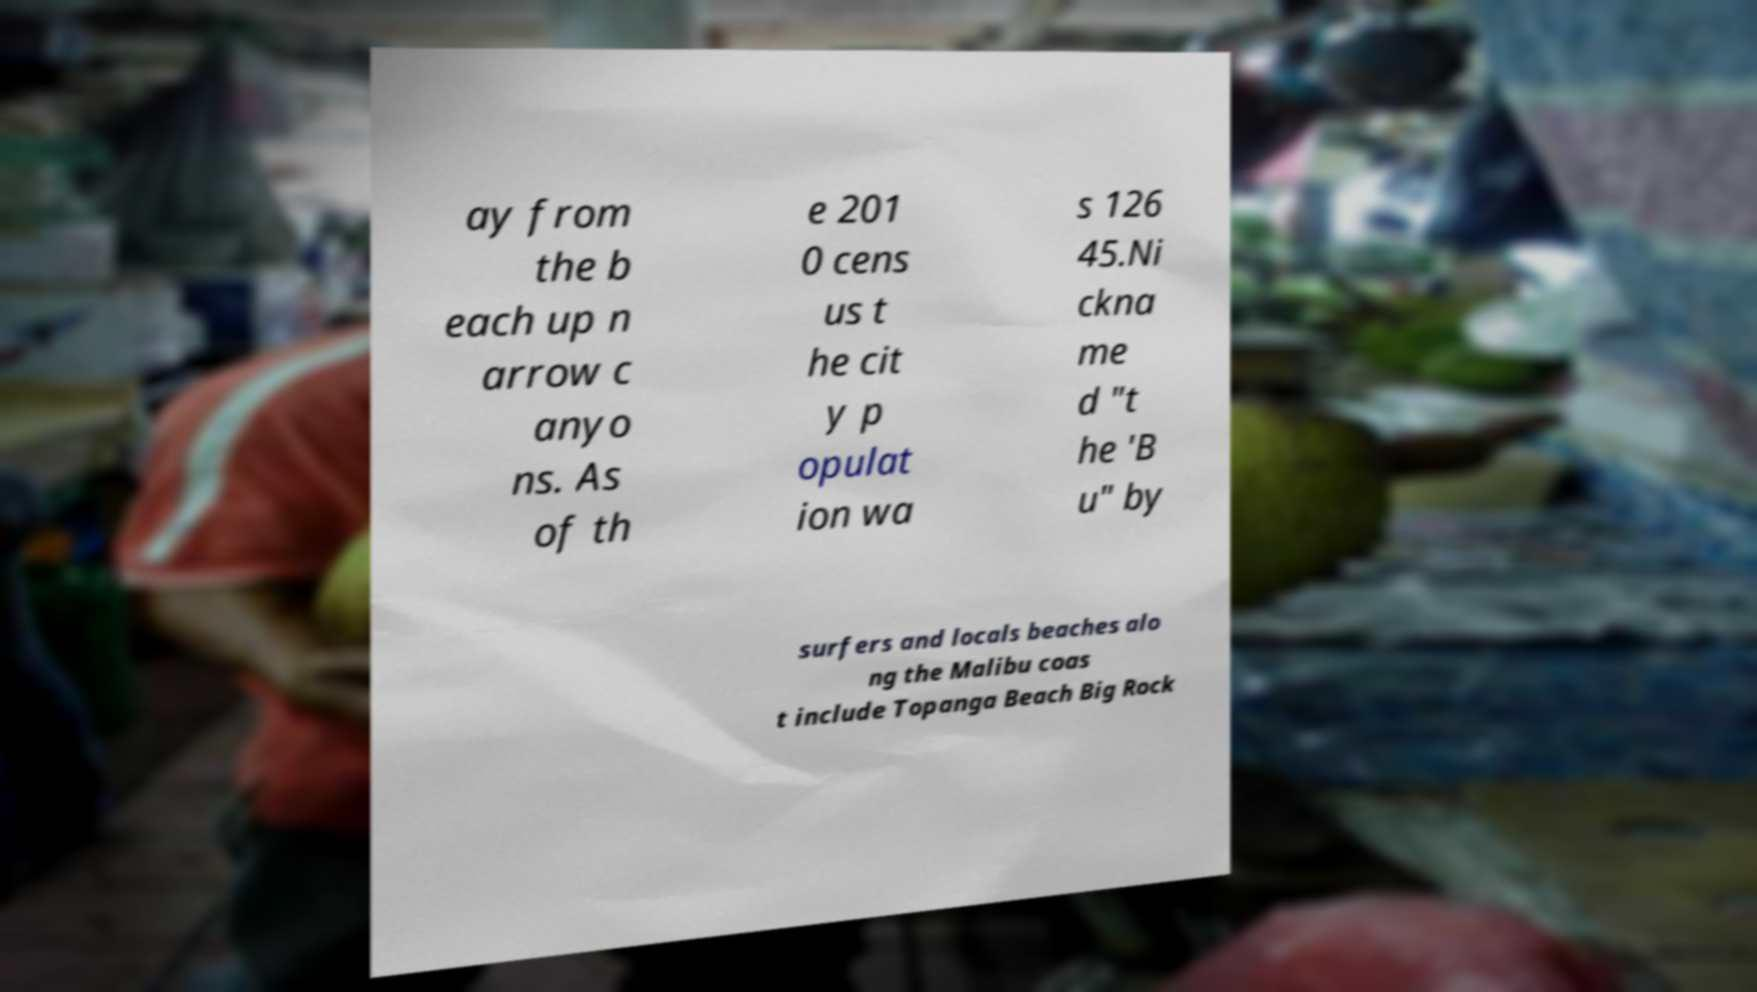Please read and relay the text visible in this image. What does it say? ay from the b each up n arrow c anyo ns. As of th e 201 0 cens us t he cit y p opulat ion wa s 126 45.Ni ckna me d "t he 'B u" by surfers and locals beaches alo ng the Malibu coas t include Topanga Beach Big Rock 